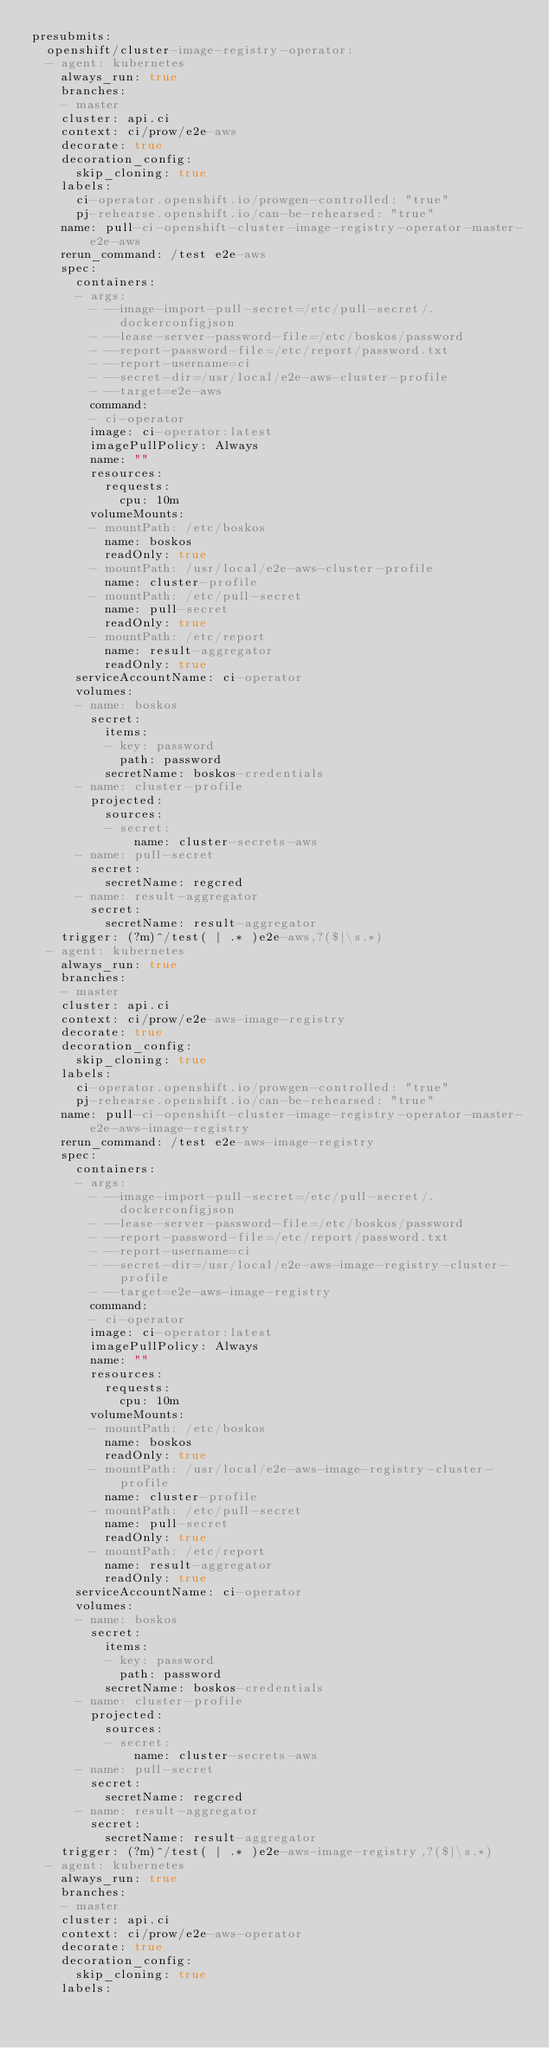<code> <loc_0><loc_0><loc_500><loc_500><_YAML_>presubmits:
  openshift/cluster-image-registry-operator:
  - agent: kubernetes
    always_run: true
    branches:
    - master
    cluster: api.ci
    context: ci/prow/e2e-aws
    decorate: true
    decoration_config:
      skip_cloning: true
    labels:
      ci-operator.openshift.io/prowgen-controlled: "true"
      pj-rehearse.openshift.io/can-be-rehearsed: "true"
    name: pull-ci-openshift-cluster-image-registry-operator-master-e2e-aws
    rerun_command: /test e2e-aws
    spec:
      containers:
      - args:
        - --image-import-pull-secret=/etc/pull-secret/.dockerconfigjson
        - --lease-server-password-file=/etc/boskos/password
        - --report-password-file=/etc/report/password.txt
        - --report-username=ci
        - --secret-dir=/usr/local/e2e-aws-cluster-profile
        - --target=e2e-aws
        command:
        - ci-operator
        image: ci-operator:latest
        imagePullPolicy: Always
        name: ""
        resources:
          requests:
            cpu: 10m
        volumeMounts:
        - mountPath: /etc/boskos
          name: boskos
          readOnly: true
        - mountPath: /usr/local/e2e-aws-cluster-profile
          name: cluster-profile
        - mountPath: /etc/pull-secret
          name: pull-secret
          readOnly: true
        - mountPath: /etc/report
          name: result-aggregator
          readOnly: true
      serviceAccountName: ci-operator
      volumes:
      - name: boskos
        secret:
          items:
          - key: password
            path: password
          secretName: boskos-credentials
      - name: cluster-profile
        projected:
          sources:
          - secret:
              name: cluster-secrets-aws
      - name: pull-secret
        secret:
          secretName: regcred
      - name: result-aggregator
        secret:
          secretName: result-aggregator
    trigger: (?m)^/test( | .* )e2e-aws,?($|\s.*)
  - agent: kubernetes
    always_run: true
    branches:
    - master
    cluster: api.ci
    context: ci/prow/e2e-aws-image-registry
    decorate: true
    decoration_config:
      skip_cloning: true
    labels:
      ci-operator.openshift.io/prowgen-controlled: "true"
      pj-rehearse.openshift.io/can-be-rehearsed: "true"
    name: pull-ci-openshift-cluster-image-registry-operator-master-e2e-aws-image-registry
    rerun_command: /test e2e-aws-image-registry
    spec:
      containers:
      - args:
        - --image-import-pull-secret=/etc/pull-secret/.dockerconfigjson
        - --lease-server-password-file=/etc/boskos/password
        - --report-password-file=/etc/report/password.txt
        - --report-username=ci
        - --secret-dir=/usr/local/e2e-aws-image-registry-cluster-profile
        - --target=e2e-aws-image-registry
        command:
        - ci-operator
        image: ci-operator:latest
        imagePullPolicy: Always
        name: ""
        resources:
          requests:
            cpu: 10m
        volumeMounts:
        - mountPath: /etc/boskos
          name: boskos
          readOnly: true
        - mountPath: /usr/local/e2e-aws-image-registry-cluster-profile
          name: cluster-profile
        - mountPath: /etc/pull-secret
          name: pull-secret
          readOnly: true
        - mountPath: /etc/report
          name: result-aggregator
          readOnly: true
      serviceAccountName: ci-operator
      volumes:
      - name: boskos
        secret:
          items:
          - key: password
            path: password
          secretName: boskos-credentials
      - name: cluster-profile
        projected:
          sources:
          - secret:
              name: cluster-secrets-aws
      - name: pull-secret
        secret:
          secretName: regcred
      - name: result-aggregator
        secret:
          secretName: result-aggregator
    trigger: (?m)^/test( | .* )e2e-aws-image-registry,?($|\s.*)
  - agent: kubernetes
    always_run: true
    branches:
    - master
    cluster: api.ci
    context: ci/prow/e2e-aws-operator
    decorate: true
    decoration_config:
      skip_cloning: true
    labels:</code> 